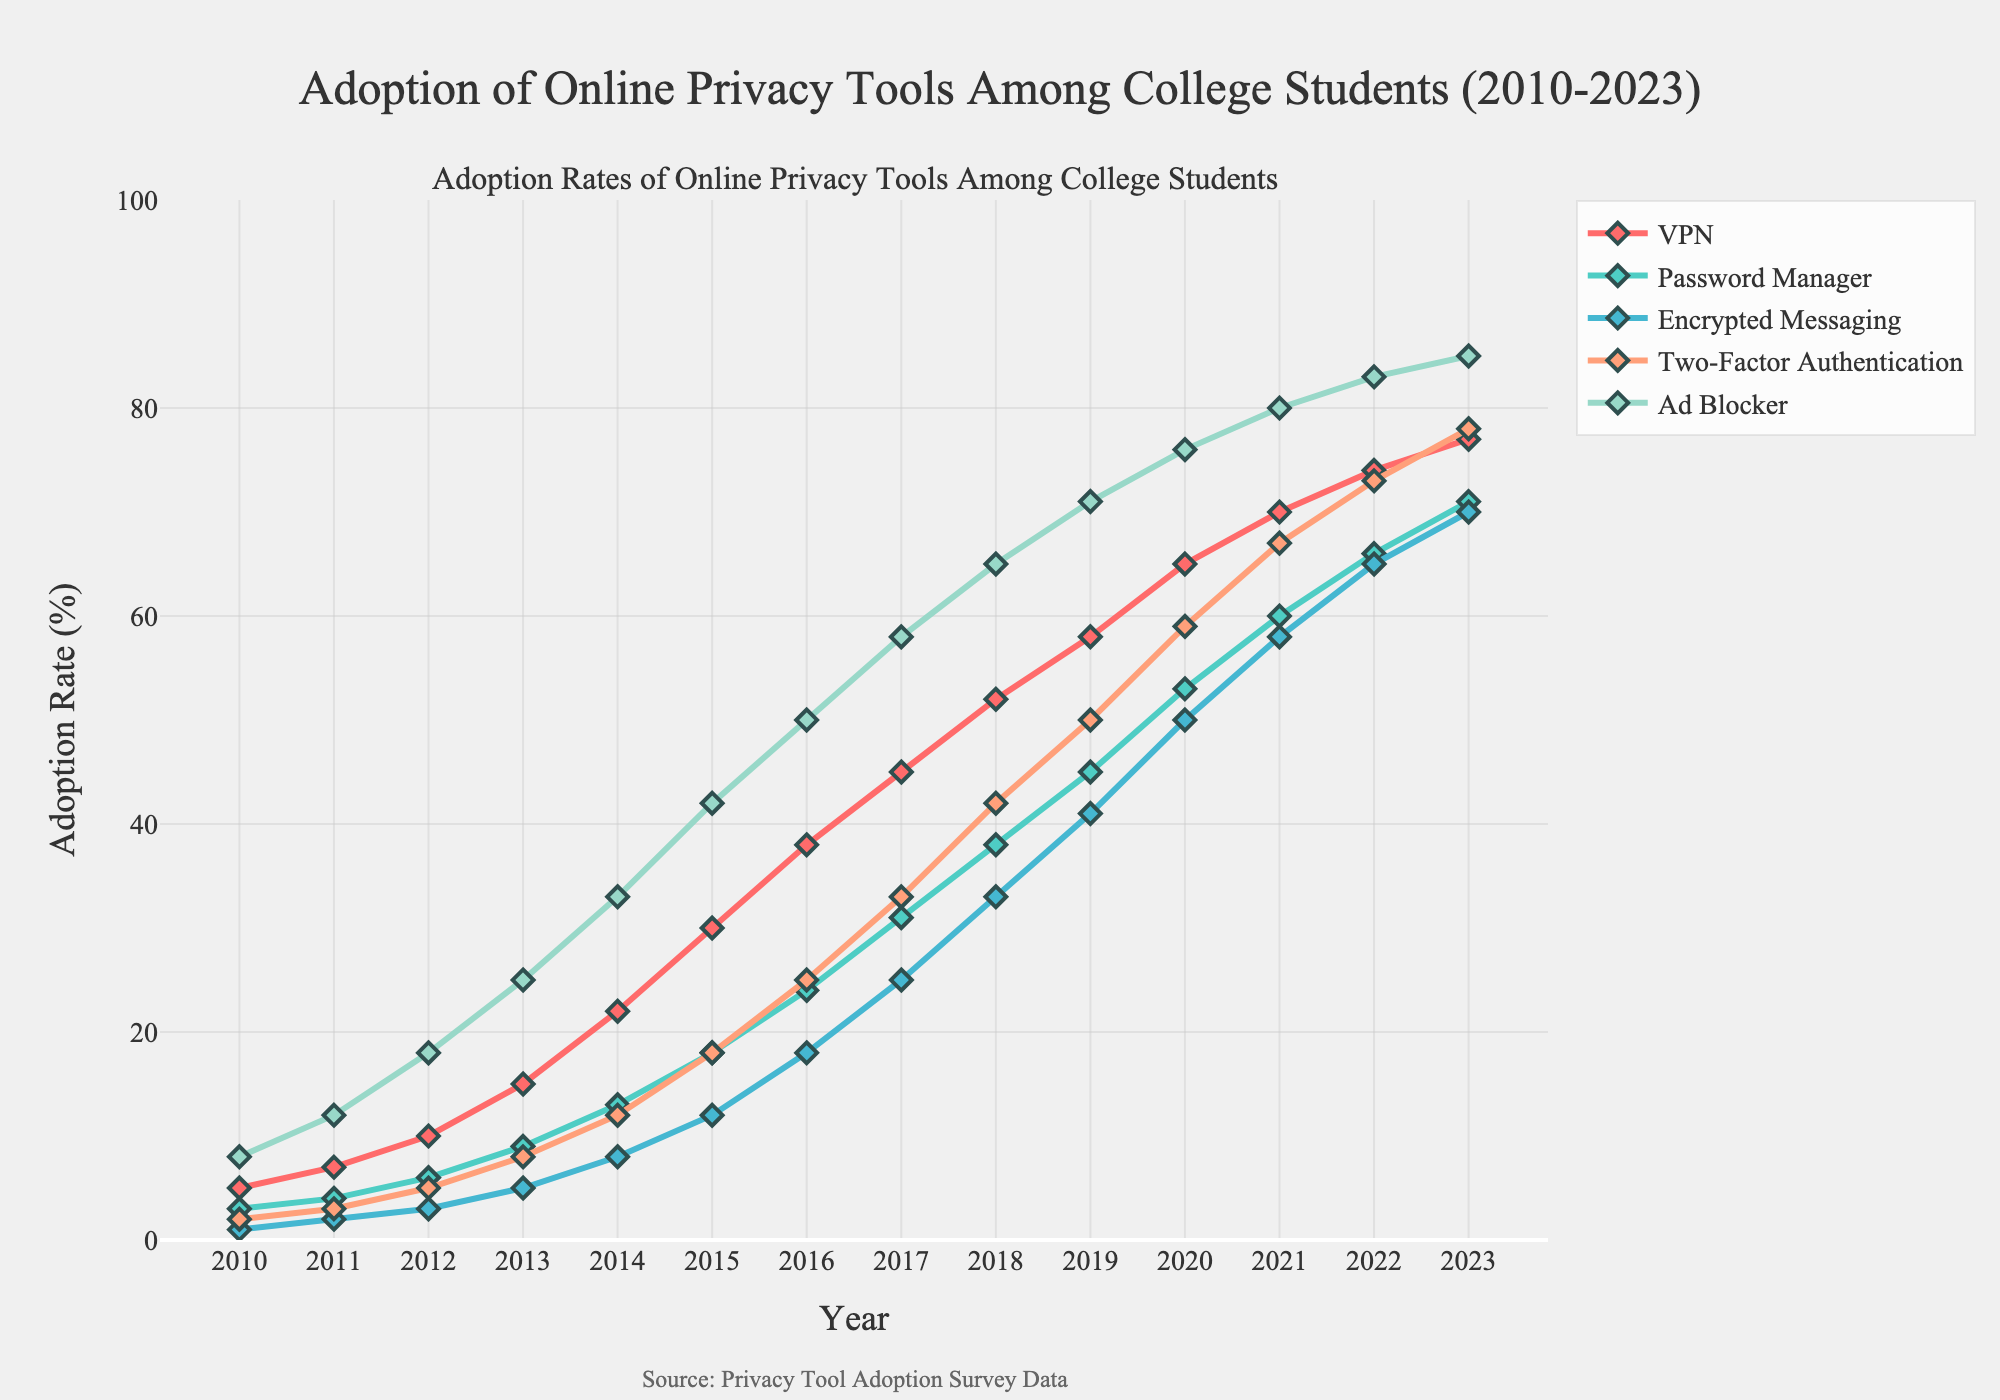What trend do we observe in the adoption rate of VPN tools between 2010 and 2023? Observe the VPN line from 2010 to 2023; it shows a steady upward trend, indicating increasing adoption among college students every year.
Answer: Upward trend Which privacy tool had the highest adoption rate in 2023? Look at the end points of all the lines in 2023. The Ad Blocker line is the highest among all the tools, indicating it has the highest adoption rate in 2023.
Answer: Ad Blocker By how much did the adoption rate of Two-Factor Authentication increase from 2012 to 2020? Find the adoption rate of Two-Factor Authentication in 2012 (5%) and in 2020 (59%). Calculate the difference: 59% - 5% = 54%.
Answer: 54% Which year shows the highest growth in the adoption rate of Encrypted Messaging tools? Compare the yearly increments in the Encrypted Messaging line. The biggest jump is from 2013 (5%) to 2014 (8%), showing an increment of 3%.
Answer: 2013 to 2014 Calculate the average adoption rate of Password Managers from 2010 to 2015. Sum the adoption rates from 2010 to 2015: 3% + 4% + 6% + 9% + 13% + 18% = 53%. Divide by the number of years (6): 53/6 ≈ 8.83%.
Answer: 8.83% Which privacy tool showed the least adoption rate improvement over the entire period from 2010 to 2023? Calculate the difference in adoption rates between 2010 and 2023 for all tools. VPN: 77-5=72, Password Manager: 71-3=68, Encrypted Messaging: 70-1=69, Two-Factor Authentication: 78-2=76, Ad Blocker: 85-8=77. Password Manager has the smallest improvement of 68%.
Answer: Password Manager Compare the adoption rates of VPN and Ad Blocker in 2015. Which one was higher and by how much? Look at the adoption rates for VPN (30%) and Ad Blocker (42%) in 2015. Subtract VPN from Ad Blocker: 42% - 30% = 12%. Ad Blocker is higher by 12%.
Answer: Ad Blocker by 12% What was the adoption rate of Password Managers in 2021? Locate the Password Manager line in 2021, where the adoption rate is 60%.
Answer: 60% Describe the visual trend of the Encrypted Messaging adoption rate from 2010 to 2023 using natural language terms like "rapid", "slow", etc. Observe the Encrypted Messaging line. It shows a slow initial increase, becoming rapid from 2014 onwards until it levels off a bit towards 2023.
Answer: Slow to rapid increase If we sum the adoption rates of all privacy tools in 2013, what value do we get? Add up the adoption rates for all tools in 2013: VPN (15%), Password Manager (9%), Encrypted Messaging (5%), Two-Factor Authentication (8%), Ad Blocker (25%). Sum: 15 + 9 + 5 + 8 + 25 = 62%.
Answer: 62% 